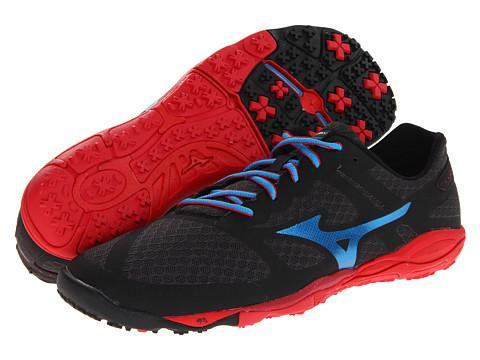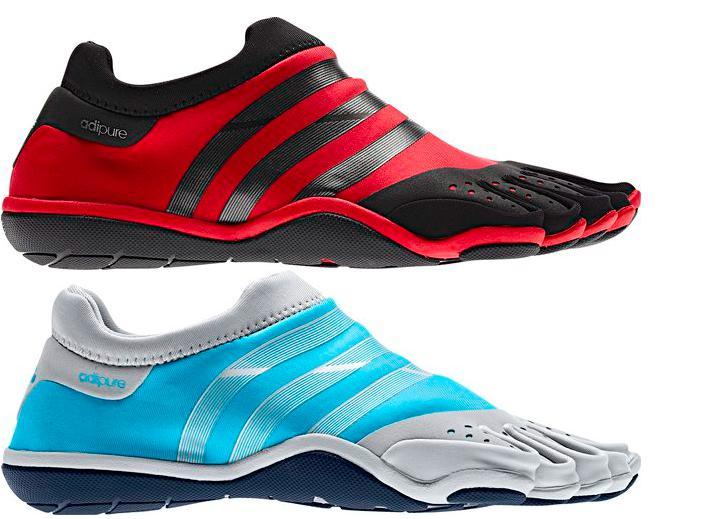The first image is the image on the left, the second image is the image on the right. For the images shown, is this caption "The shoe style in one image is black with pink and white accents, and tied with black laces with pink edging." true? Answer yes or no. No. The first image is the image on the left, the second image is the image on the right. Examine the images to the left and right. Is the description "Each image contains exactly one athletic shoe shown at an angle." accurate? Answer yes or no. No. 